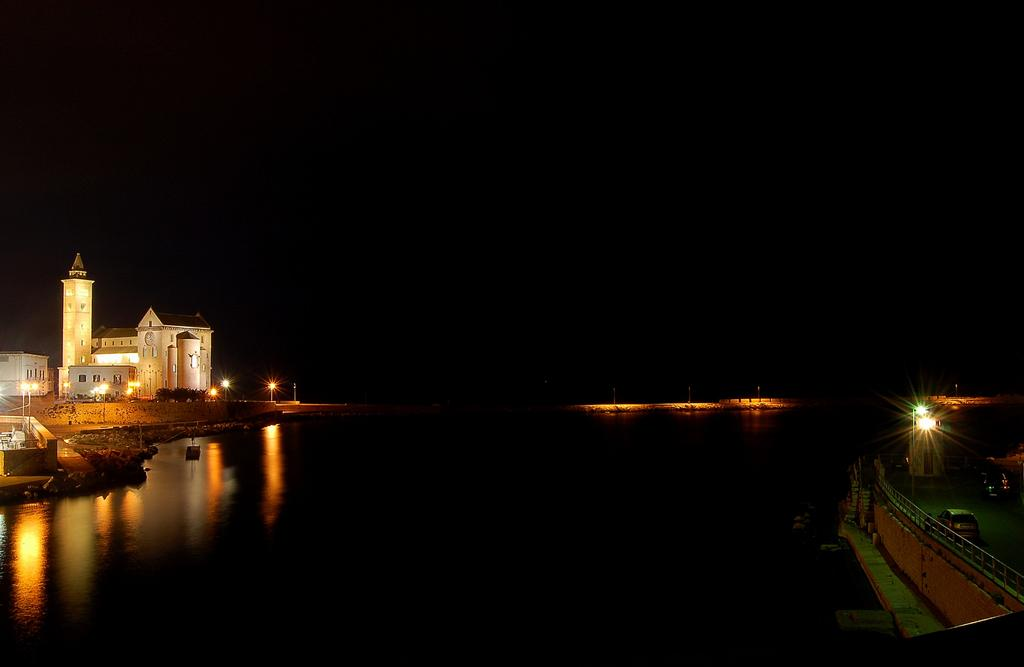What type of structures can be seen in the image? There are buildings in the image. What are the light sources in the image? There are light poles in the image. What type of vegetation is present in the image? There are trees in the image. What natural element is visible in the image? There is water visible in the image. What type of transportation can be seen in the image? There are vehicles on the road in the image. How would you describe the lighting in the image? The image is dark. What type of pail is being used to represent the nation in the image? There is no pail present in the image, nor is there any representation of a nation. What country is depicted in the image? The image does not depict any specific country; it contains buildings, light poles, trees, water, vehicles, and is dark. 